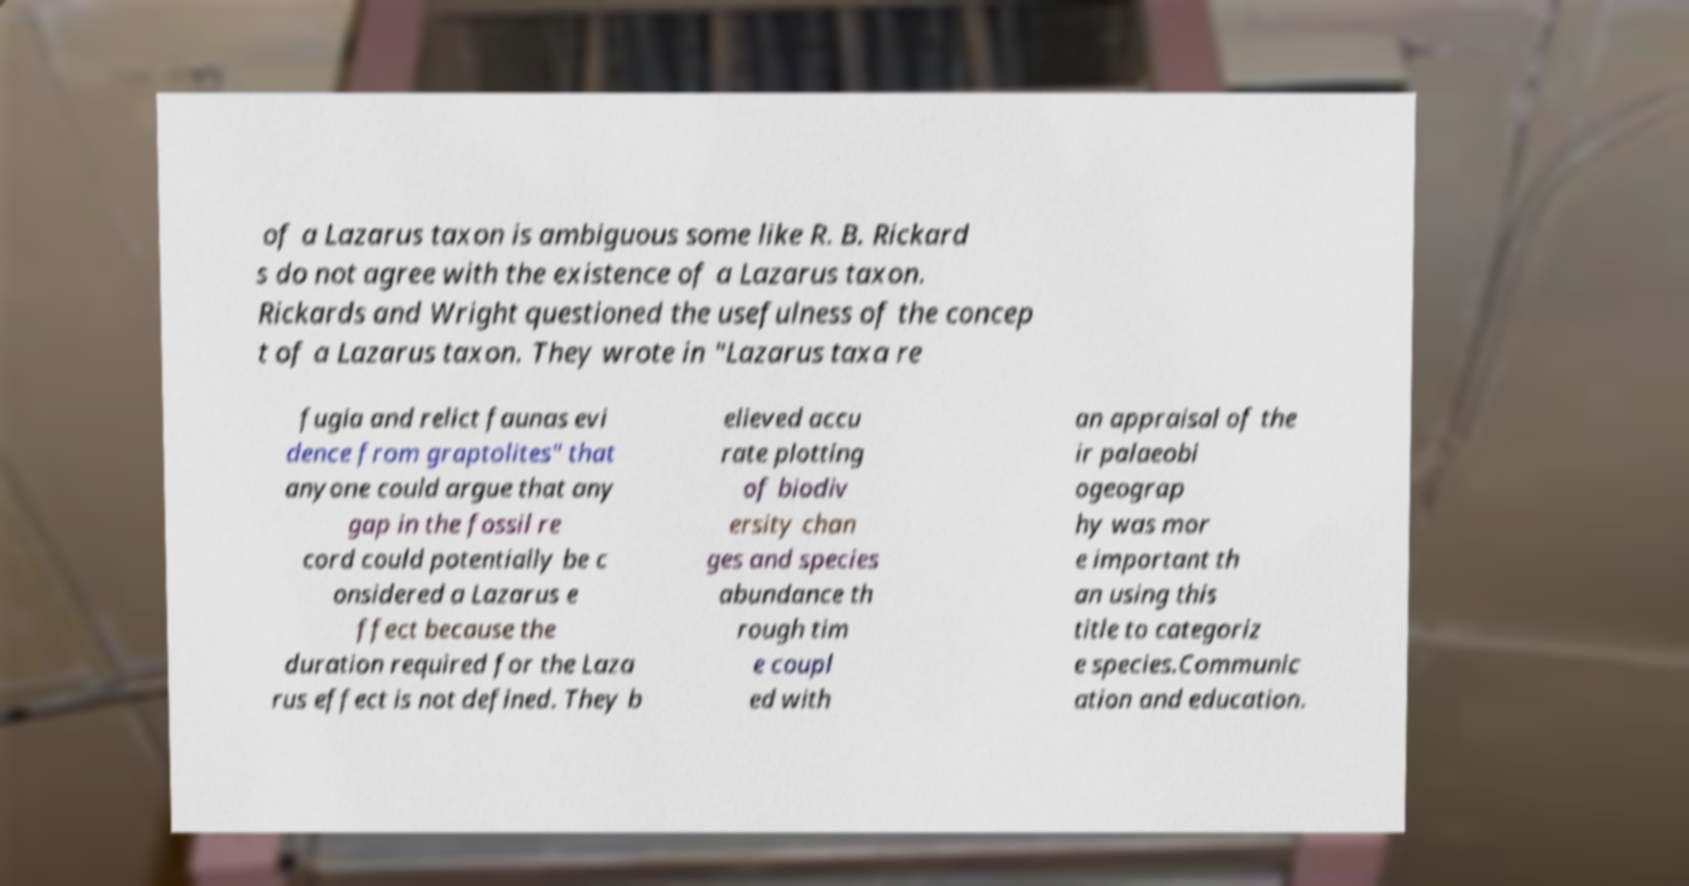There's text embedded in this image that I need extracted. Can you transcribe it verbatim? of a Lazarus taxon is ambiguous some like R. B. Rickard s do not agree with the existence of a Lazarus taxon. Rickards and Wright questioned the usefulness of the concep t of a Lazarus taxon. They wrote in "Lazarus taxa re fugia and relict faunas evi dence from graptolites" that anyone could argue that any gap in the fossil re cord could potentially be c onsidered a Lazarus e ffect because the duration required for the Laza rus effect is not defined. They b elieved accu rate plotting of biodiv ersity chan ges and species abundance th rough tim e coupl ed with an appraisal of the ir palaeobi ogeograp hy was mor e important th an using this title to categoriz e species.Communic ation and education. 